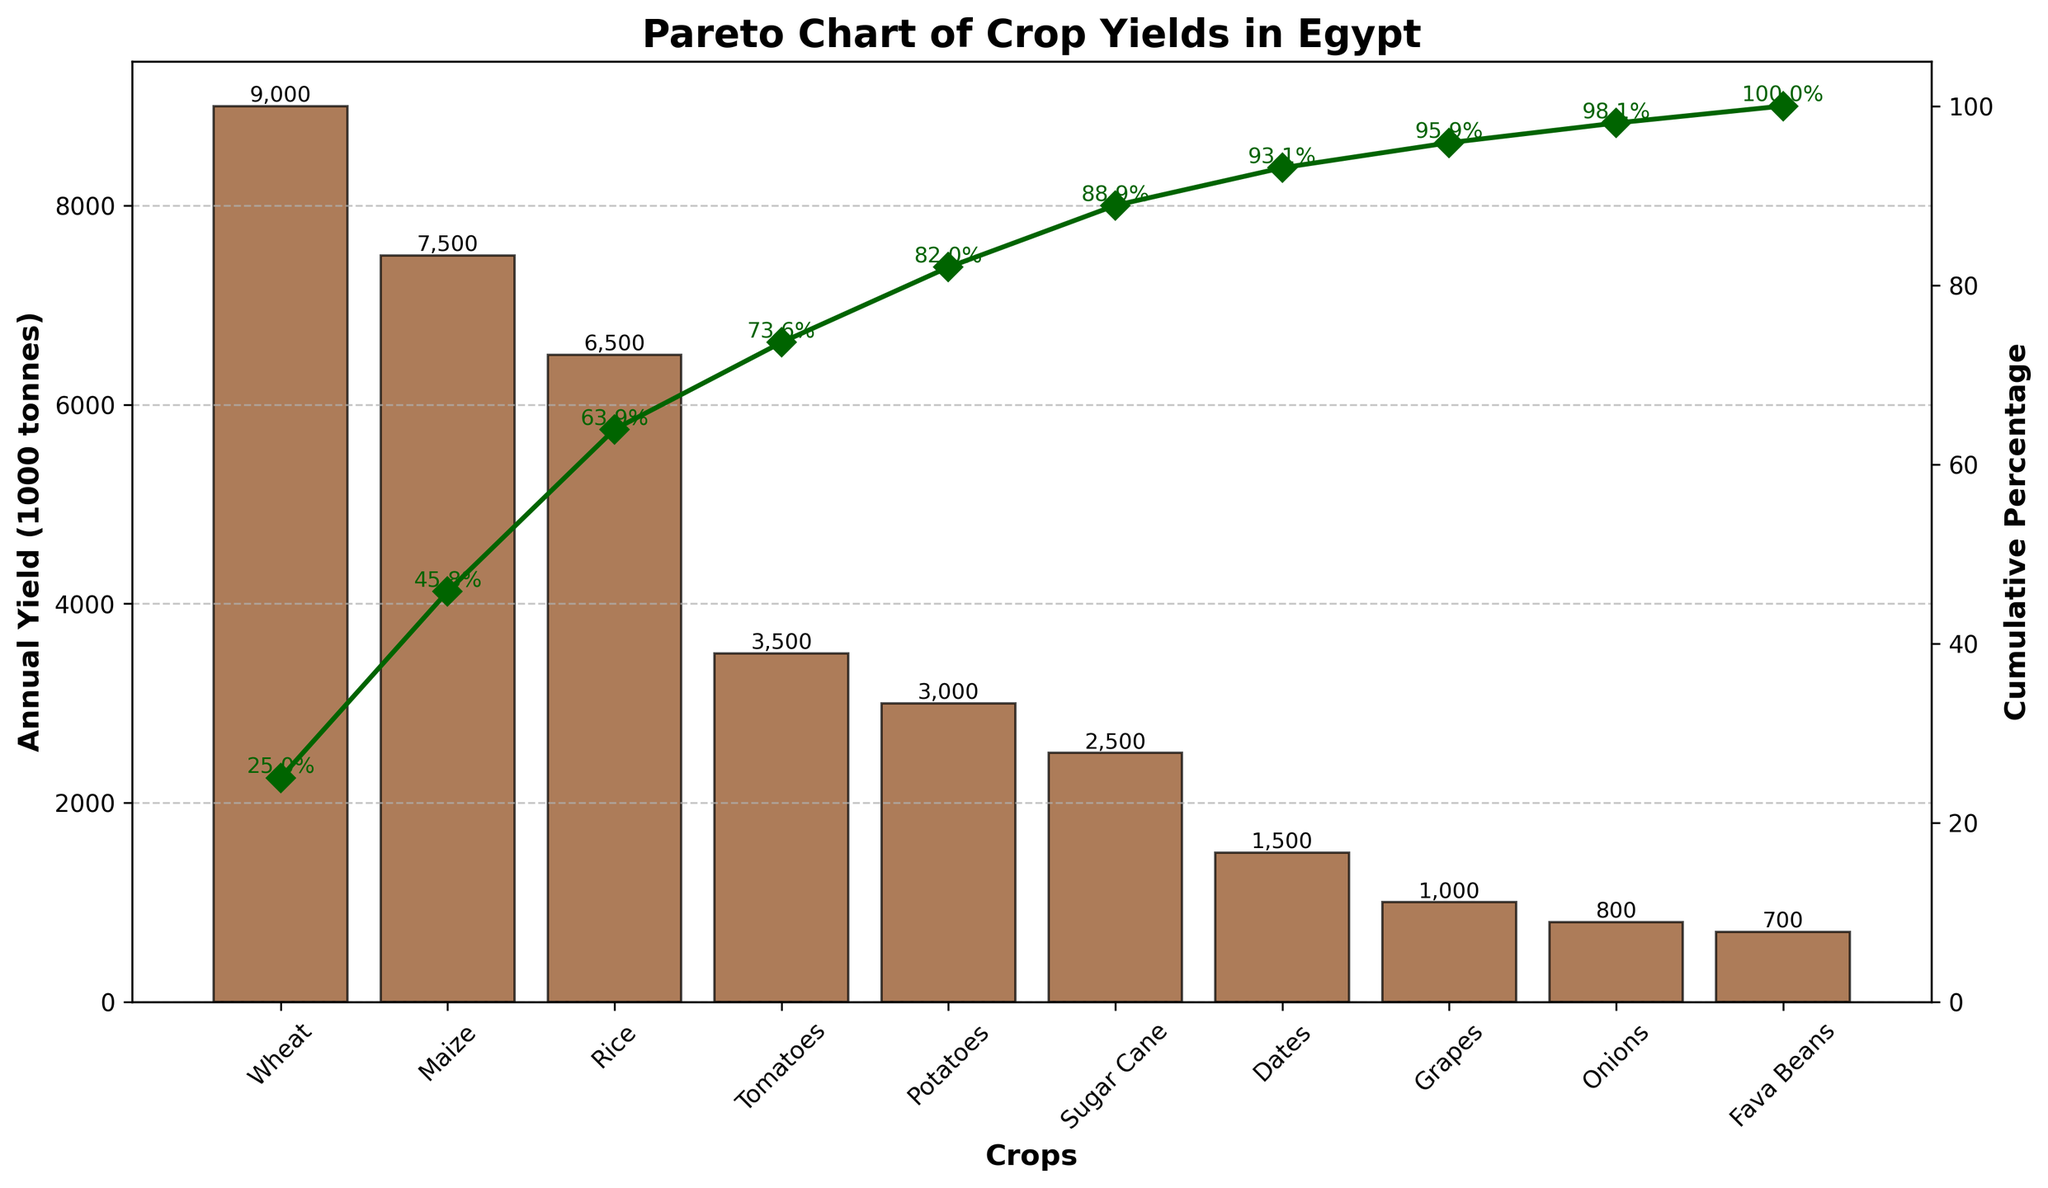What is the title of the figure? The title of the figure is located at the top center and usually indicates the main topic or purpose of the chart. Here, it reads "Pareto Chart of Crop Yields in Egypt".
Answer: Pareto Chart of Crop Yields in Egypt Which crop has the highest annual yield? The crop with the highest annual yield can be identified by looking at the tallest bar in the bar chart section of the figure. The tallest bar represents Wheat, which has an annual yield of 9000 thousand tonnes.
Answer: Wheat What is the cumulative percentage of the top three crops? To find this, check the cumulative percentage line for the third crop listed on the x-axis. The cumulative percentage for Wheat, Maize, and Rice combined is 63.9%.
Answer: 63.9% How many crops have an annual yield greater than 3000 thousand tonnes? Identify the bars that have heights greater than the 3000 mark on the y-axis. The crops with yields greater than 3000 are Wheat, Maize, Rice, and Tomatoes, making a total of 4 crops.
Answer: 4 Which crop is responsible for reaching the cumulative percentage of 100%? The last data point (or the point at the 100% cumulative mark) in the cumulative percentage series indicates the crop responsible for reaching 100%. Here, it is Fava Beans.
Answer: Fava Beans What is the difference in the annual yield between Tomatoes and Onions? The yields for Tomatoes and Onions are 3500 and 800 thousand tonnes, respectively. The difference is calculated by subtracting the smaller number from the larger one: 3500 - 800.
Answer: 2700 How many crops contribute to over 80% of the cumulative percentage? Check the cumulative percentage line and count the crops until the 80% mark is exceeded. The cumulative percentage exceeds 80% after the first five crops (Wheat, Maize, Rice, Tomatoes, Potatoes).
Answer: 5 Which crop has the smallest annual yield? The crop with the smallest annual yield is represented by the shortest bar in the bar chart. Fava Beans have the smallest yield at 700 thousand tonnes.
Answer: Fava Beans Is the annual yield of Grapes more or less than Dates? By comparing the heights of the bars for Grapes and Dates, you'll find that Grapes have a smaller yield than Dates (1000 vs. 1500 thousand tonnes).
Answer: Less What is the total annual yield of Wheat and Rice combined? Add the annual yield values of Wheat and Rice: 9000 + 6500 = 15500 thousand tonnes.
Answer: 15500 